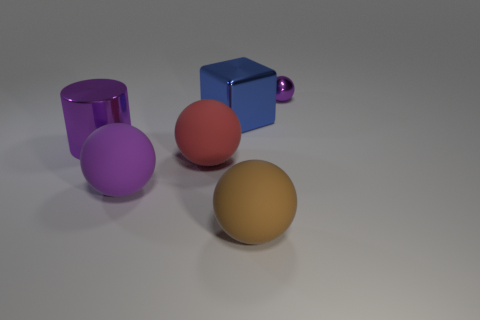What number of other objects are the same material as the large red ball?
Make the answer very short. 2. Are there the same number of big purple metallic things that are behind the purple shiny sphere and cyan rubber cylinders?
Offer a terse response. Yes. What is the material of the large thing that is behind the purple shiny thing in front of the small purple object behind the brown object?
Your answer should be very brief. Metal. There is a sphere on the right side of the brown object; what color is it?
Your answer should be very brief. Purple. Is there anything else that is the same shape as the blue object?
Ensure brevity in your answer.  No. There is a rubber ball in front of the purple ball left of the tiny purple ball; how big is it?
Make the answer very short. Large. Is the number of big brown rubber things that are in front of the big brown matte thing the same as the number of large red matte things behind the cylinder?
Make the answer very short. Yes. Are there any other things that have the same size as the purple shiny sphere?
Offer a very short reply. No. There is a big cylinder that is the same material as the large cube; what is its color?
Your answer should be very brief. Purple. Does the cylinder have the same material as the large ball on the right side of the blue shiny cube?
Your answer should be compact. No. 